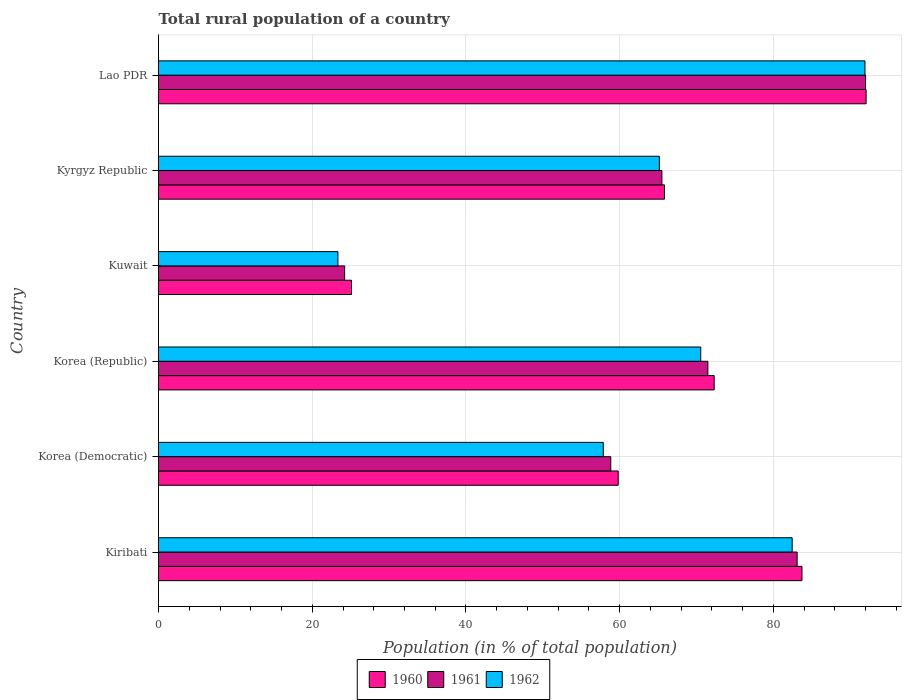How many different coloured bars are there?
Your response must be concise. 3. How many groups of bars are there?
Provide a succinct answer. 6. Are the number of bars per tick equal to the number of legend labels?
Provide a short and direct response. Yes. Are the number of bars on each tick of the Y-axis equal?
Your response must be concise. Yes. What is the label of the 2nd group of bars from the top?
Offer a terse response. Kyrgyz Republic. What is the rural population in 1962 in Kiribati?
Keep it short and to the point. 82.43. Across all countries, what is the maximum rural population in 1961?
Your answer should be compact. 91.98. Across all countries, what is the minimum rural population in 1960?
Offer a very short reply. 25.11. In which country was the rural population in 1962 maximum?
Offer a very short reply. Lao PDR. In which country was the rural population in 1961 minimum?
Make the answer very short. Kuwait. What is the total rural population in 1961 in the graph?
Your answer should be compact. 395.07. What is the difference between the rural population in 1960 in Korea (Democratic) and that in Kuwait?
Your answer should be compact. 34.7. What is the difference between the rural population in 1961 in Lao PDR and the rural population in 1962 in Korea (Democratic)?
Offer a very short reply. 34.12. What is the average rural population in 1962 per country?
Offer a very short reply. 65.21. What is the difference between the rural population in 1961 and rural population in 1960 in Kiribati?
Provide a short and direct response. -0.63. In how many countries, is the rural population in 1962 greater than 68 %?
Provide a succinct answer. 3. What is the ratio of the rural population in 1960 in Kiribati to that in Korea (Republic)?
Give a very brief answer. 1.16. What is the difference between the highest and the second highest rural population in 1960?
Ensure brevity in your answer.  8.34. What is the difference between the highest and the lowest rural population in 1960?
Make the answer very short. 66.95. Is the sum of the rural population in 1960 in Kyrgyz Republic and Lao PDR greater than the maximum rural population in 1962 across all countries?
Offer a terse response. Yes. What does the 1st bar from the bottom in Kyrgyz Republic represents?
Provide a short and direct response. 1960. Are all the bars in the graph horizontal?
Provide a succinct answer. Yes. How many countries are there in the graph?
Make the answer very short. 6. What is the difference between two consecutive major ticks on the X-axis?
Offer a terse response. 20. Does the graph contain any zero values?
Offer a terse response. No. Does the graph contain grids?
Ensure brevity in your answer.  Yes. Where does the legend appear in the graph?
Provide a succinct answer. Bottom center. How are the legend labels stacked?
Make the answer very short. Horizontal. What is the title of the graph?
Offer a very short reply. Total rural population of a country. What is the label or title of the X-axis?
Your response must be concise. Population (in % of total population). What is the Population (in % of total population) in 1960 in Kiribati?
Give a very brief answer. 83.71. What is the Population (in % of total population) in 1961 in Kiribati?
Ensure brevity in your answer.  83.08. What is the Population (in % of total population) in 1962 in Kiribati?
Your answer should be very brief. 82.43. What is the Population (in % of total population) in 1960 in Korea (Democratic)?
Offer a terse response. 59.8. What is the Population (in % of total population) in 1961 in Korea (Democratic)?
Your response must be concise. 58.84. What is the Population (in % of total population) in 1962 in Korea (Democratic)?
Your answer should be very brief. 57.86. What is the Population (in % of total population) in 1960 in Korea (Republic)?
Your answer should be very brief. 72.29. What is the Population (in % of total population) in 1961 in Korea (Republic)?
Keep it short and to the point. 71.47. What is the Population (in % of total population) of 1962 in Korea (Republic)?
Provide a succinct answer. 70.54. What is the Population (in % of total population) in 1960 in Kuwait?
Provide a succinct answer. 25.11. What is the Population (in % of total population) in 1961 in Kuwait?
Ensure brevity in your answer.  24.21. What is the Population (in % of total population) in 1962 in Kuwait?
Offer a very short reply. 23.34. What is the Population (in % of total population) in 1960 in Kyrgyz Republic?
Ensure brevity in your answer.  65.82. What is the Population (in % of total population) of 1961 in Kyrgyz Republic?
Provide a succinct answer. 65.49. What is the Population (in % of total population) of 1962 in Kyrgyz Republic?
Provide a succinct answer. 65.16. What is the Population (in % of total population) of 1960 in Lao PDR?
Make the answer very short. 92.05. What is the Population (in % of total population) in 1961 in Lao PDR?
Offer a very short reply. 91.98. What is the Population (in % of total population) in 1962 in Lao PDR?
Offer a very short reply. 91.91. Across all countries, what is the maximum Population (in % of total population) in 1960?
Your answer should be very brief. 92.05. Across all countries, what is the maximum Population (in % of total population) in 1961?
Make the answer very short. 91.98. Across all countries, what is the maximum Population (in % of total population) of 1962?
Ensure brevity in your answer.  91.91. Across all countries, what is the minimum Population (in % of total population) in 1960?
Ensure brevity in your answer.  25.11. Across all countries, what is the minimum Population (in % of total population) in 1961?
Offer a terse response. 24.21. Across all countries, what is the minimum Population (in % of total population) in 1962?
Your answer should be very brief. 23.34. What is the total Population (in % of total population) of 1960 in the graph?
Provide a succinct answer. 398.79. What is the total Population (in % of total population) of 1961 in the graph?
Offer a terse response. 395.07. What is the total Population (in % of total population) of 1962 in the graph?
Ensure brevity in your answer.  391.24. What is the difference between the Population (in % of total population) in 1960 in Kiribati and that in Korea (Democratic)?
Offer a very short reply. 23.91. What is the difference between the Population (in % of total population) in 1961 in Kiribati and that in Korea (Democratic)?
Offer a terse response. 24.24. What is the difference between the Population (in % of total population) of 1962 in Kiribati and that in Korea (Democratic)?
Offer a terse response. 24.57. What is the difference between the Population (in % of total population) in 1960 in Kiribati and that in Korea (Republic)?
Your answer should be compact. 11.42. What is the difference between the Population (in % of total population) in 1961 in Kiribati and that in Korea (Republic)?
Provide a succinct answer. 11.61. What is the difference between the Population (in % of total population) in 1962 in Kiribati and that in Korea (Republic)?
Make the answer very short. 11.89. What is the difference between the Population (in % of total population) in 1960 in Kiribati and that in Kuwait?
Keep it short and to the point. 58.6. What is the difference between the Population (in % of total population) of 1961 in Kiribati and that in Kuwait?
Offer a terse response. 58.87. What is the difference between the Population (in % of total population) in 1962 in Kiribati and that in Kuwait?
Provide a succinct answer. 59.09. What is the difference between the Population (in % of total population) of 1960 in Kiribati and that in Kyrgyz Republic?
Give a very brief answer. 17.89. What is the difference between the Population (in % of total population) in 1961 in Kiribati and that in Kyrgyz Republic?
Provide a succinct answer. 17.59. What is the difference between the Population (in % of total population) of 1962 in Kiribati and that in Kyrgyz Republic?
Ensure brevity in your answer.  17.28. What is the difference between the Population (in % of total population) of 1960 in Kiribati and that in Lao PDR?
Provide a succinct answer. -8.34. What is the difference between the Population (in % of total population) of 1961 in Kiribati and that in Lao PDR?
Your answer should be very brief. -8.9. What is the difference between the Population (in % of total population) of 1962 in Kiribati and that in Lao PDR?
Provide a succinct answer. -9.47. What is the difference between the Population (in % of total population) of 1960 in Korea (Democratic) and that in Korea (Republic)?
Make the answer very short. -12.48. What is the difference between the Population (in % of total population) in 1961 in Korea (Democratic) and that in Korea (Republic)?
Your response must be concise. -12.63. What is the difference between the Population (in % of total population) in 1962 in Korea (Democratic) and that in Korea (Republic)?
Your response must be concise. -12.68. What is the difference between the Population (in % of total population) in 1960 in Korea (Democratic) and that in Kuwait?
Your answer should be compact. 34.7. What is the difference between the Population (in % of total population) of 1961 in Korea (Democratic) and that in Kuwait?
Provide a short and direct response. 34.62. What is the difference between the Population (in % of total population) of 1962 in Korea (Democratic) and that in Kuwait?
Your response must be concise. 34.52. What is the difference between the Population (in % of total population) in 1960 in Korea (Democratic) and that in Kyrgyz Republic?
Give a very brief answer. -6.01. What is the difference between the Population (in % of total population) of 1961 in Korea (Democratic) and that in Kyrgyz Republic?
Your answer should be very brief. -6.65. What is the difference between the Population (in % of total population) of 1962 in Korea (Democratic) and that in Kyrgyz Republic?
Keep it short and to the point. -7.29. What is the difference between the Population (in % of total population) in 1960 in Korea (Democratic) and that in Lao PDR?
Your answer should be compact. -32.25. What is the difference between the Population (in % of total population) in 1961 in Korea (Democratic) and that in Lao PDR?
Offer a very short reply. -33.14. What is the difference between the Population (in % of total population) of 1962 in Korea (Democratic) and that in Lao PDR?
Offer a very short reply. -34.04. What is the difference between the Population (in % of total population) of 1960 in Korea (Republic) and that in Kuwait?
Provide a succinct answer. 47.18. What is the difference between the Population (in % of total population) of 1961 in Korea (Republic) and that in Kuwait?
Provide a succinct answer. 47.26. What is the difference between the Population (in % of total population) in 1962 in Korea (Republic) and that in Kuwait?
Your answer should be very brief. 47.2. What is the difference between the Population (in % of total population) of 1960 in Korea (Republic) and that in Kyrgyz Republic?
Offer a terse response. 6.47. What is the difference between the Population (in % of total population) in 1961 in Korea (Republic) and that in Kyrgyz Republic?
Ensure brevity in your answer.  5.98. What is the difference between the Population (in % of total population) in 1962 in Korea (Republic) and that in Kyrgyz Republic?
Offer a very short reply. 5.38. What is the difference between the Population (in % of total population) of 1960 in Korea (Republic) and that in Lao PDR?
Give a very brief answer. -19.76. What is the difference between the Population (in % of total population) of 1961 in Korea (Republic) and that in Lao PDR?
Offer a terse response. -20.51. What is the difference between the Population (in % of total population) in 1962 in Korea (Republic) and that in Lao PDR?
Offer a terse response. -21.37. What is the difference between the Population (in % of total population) in 1960 in Kuwait and that in Kyrgyz Republic?
Your answer should be very brief. -40.71. What is the difference between the Population (in % of total population) of 1961 in Kuwait and that in Kyrgyz Republic?
Offer a terse response. -41.28. What is the difference between the Population (in % of total population) of 1962 in Kuwait and that in Kyrgyz Republic?
Keep it short and to the point. -41.82. What is the difference between the Population (in % of total population) in 1960 in Kuwait and that in Lao PDR?
Keep it short and to the point. -66.95. What is the difference between the Population (in % of total population) of 1961 in Kuwait and that in Lao PDR?
Your answer should be very brief. -67.77. What is the difference between the Population (in % of total population) of 1962 in Kuwait and that in Lao PDR?
Your response must be concise. -68.56. What is the difference between the Population (in % of total population) in 1960 in Kyrgyz Republic and that in Lao PDR?
Provide a succinct answer. -26.23. What is the difference between the Population (in % of total population) in 1961 in Kyrgyz Republic and that in Lao PDR?
Make the answer very short. -26.49. What is the difference between the Population (in % of total population) in 1962 in Kyrgyz Republic and that in Lao PDR?
Your answer should be compact. -26.75. What is the difference between the Population (in % of total population) in 1960 in Kiribati and the Population (in % of total population) in 1961 in Korea (Democratic)?
Keep it short and to the point. 24.87. What is the difference between the Population (in % of total population) of 1960 in Kiribati and the Population (in % of total population) of 1962 in Korea (Democratic)?
Give a very brief answer. 25.85. What is the difference between the Population (in % of total population) in 1961 in Kiribati and the Population (in % of total population) in 1962 in Korea (Democratic)?
Your answer should be compact. 25.22. What is the difference between the Population (in % of total population) in 1960 in Kiribati and the Population (in % of total population) in 1961 in Korea (Republic)?
Keep it short and to the point. 12.24. What is the difference between the Population (in % of total population) in 1960 in Kiribati and the Population (in % of total population) in 1962 in Korea (Republic)?
Offer a terse response. 13.17. What is the difference between the Population (in % of total population) in 1961 in Kiribati and the Population (in % of total population) in 1962 in Korea (Republic)?
Your answer should be compact. 12.54. What is the difference between the Population (in % of total population) of 1960 in Kiribati and the Population (in % of total population) of 1961 in Kuwait?
Offer a terse response. 59.5. What is the difference between the Population (in % of total population) of 1960 in Kiribati and the Population (in % of total population) of 1962 in Kuwait?
Provide a succinct answer. 60.37. What is the difference between the Population (in % of total population) of 1961 in Kiribati and the Population (in % of total population) of 1962 in Kuwait?
Ensure brevity in your answer.  59.74. What is the difference between the Population (in % of total population) of 1960 in Kiribati and the Population (in % of total population) of 1961 in Kyrgyz Republic?
Ensure brevity in your answer.  18.22. What is the difference between the Population (in % of total population) in 1960 in Kiribati and the Population (in % of total population) in 1962 in Kyrgyz Republic?
Your response must be concise. 18.55. What is the difference between the Population (in % of total population) in 1961 in Kiribati and the Population (in % of total population) in 1962 in Kyrgyz Republic?
Keep it short and to the point. 17.93. What is the difference between the Population (in % of total population) of 1960 in Kiribati and the Population (in % of total population) of 1961 in Lao PDR?
Offer a terse response. -8.27. What is the difference between the Population (in % of total population) of 1960 in Kiribati and the Population (in % of total population) of 1962 in Lao PDR?
Offer a terse response. -8.2. What is the difference between the Population (in % of total population) in 1961 in Kiribati and the Population (in % of total population) in 1962 in Lao PDR?
Your answer should be compact. -8.82. What is the difference between the Population (in % of total population) in 1960 in Korea (Democratic) and the Population (in % of total population) in 1961 in Korea (Republic)?
Your answer should be compact. -11.66. What is the difference between the Population (in % of total population) in 1960 in Korea (Democratic) and the Population (in % of total population) in 1962 in Korea (Republic)?
Make the answer very short. -10.73. What is the difference between the Population (in % of total population) in 1961 in Korea (Democratic) and the Population (in % of total population) in 1962 in Korea (Republic)?
Keep it short and to the point. -11.7. What is the difference between the Population (in % of total population) of 1960 in Korea (Democratic) and the Population (in % of total population) of 1961 in Kuwait?
Your response must be concise. 35.59. What is the difference between the Population (in % of total population) of 1960 in Korea (Democratic) and the Population (in % of total population) of 1962 in Kuwait?
Offer a terse response. 36.47. What is the difference between the Population (in % of total population) of 1961 in Korea (Democratic) and the Population (in % of total population) of 1962 in Kuwait?
Ensure brevity in your answer.  35.5. What is the difference between the Population (in % of total population) in 1960 in Korea (Democratic) and the Population (in % of total population) in 1961 in Kyrgyz Republic?
Give a very brief answer. -5.68. What is the difference between the Population (in % of total population) of 1960 in Korea (Democratic) and the Population (in % of total population) of 1962 in Kyrgyz Republic?
Keep it short and to the point. -5.35. What is the difference between the Population (in % of total population) in 1961 in Korea (Democratic) and the Population (in % of total population) in 1962 in Kyrgyz Republic?
Your response must be concise. -6.32. What is the difference between the Population (in % of total population) in 1960 in Korea (Democratic) and the Population (in % of total population) in 1961 in Lao PDR?
Offer a very short reply. -32.17. What is the difference between the Population (in % of total population) of 1960 in Korea (Democratic) and the Population (in % of total population) of 1962 in Lao PDR?
Offer a terse response. -32.1. What is the difference between the Population (in % of total population) in 1961 in Korea (Democratic) and the Population (in % of total population) in 1962 in Lao PDR?
Give a very brief answer. -33.07. What is the difference between the Population (in % of total population) in 1960 in Korea (Republic) and the Population (in % of total population) in 1961 in Kuwait?
Keep it short and to the point. 48.08. What is the difference between the Population (in % of total population) in 1960 in Korea (Republic) and the Population (in % of total population) in 1962 in Kuwait?
Your answer should be compact. 48.95. What is the difference between the Population (in % of total population) of 1961 in Korea (Republic) and the Population (in % of total population) of 1962 in Kuwait?
Give a very brief answer. 48.13. What is the difference between the Population (in % of total population) of 1960 in Korea (Republic) and the Population (in % of total population) of 1961 in Kyrgyz Republic?
Provide a succinct answer. 6.8. What is the difference between the Population (in % of total population) in 1960 in Korea (Republic) and the Population (in % of total population) in 1962 in Kyrgyz Republic?
Your answer should be compact. 7.13. What is the difference between the Population (in % of total population) in 1961 in Korea (Republic) and the Population (in % of total population) in 1962 in Kyrgyz Republic?
Your answer should be compact. 6.31. What is the difference between the Population (in % of total population) in 1960 in Korea (Republic) and the Population (in % of total population) in 1961 in Lao PDR?
Keep it short and to the point. -19.69. What is the difference between the Population (in % of total population) of 1960 in Korea (Republic) and the Population (in % of total population) of 1962 in Lao PDR?
Give a very brief answer. -19.61. What is the difference between the Population (in % of total population) of 1961 in Korea (Republic) and the Population (in % of total population) of 1962 in Lao PDR?
Ensure brevity in your answer.  -20.44. What is the difference between the Population (in % of total population) of 1960 in Kuwait and the Population (in % of total population) of 1961 in Kyrgyz Republic?
Keep it short and to the point. -40.38. What is the difference between the Population (in % of total population) in 1960 in Kuwait and the Population (in % of total population) in 1962 in Kyrgyz Republic?
Provide a short and direct response. -40.05. What is the difference between the Population (in % of total population) of 1961 in Kuwait and the Population (in % of total population) of 1962 in Kyrgyz Republic?
Your answer should be very brief. -40.94. What is the difference between the Population (in % of total population) of 1960 in Kuwait and the Population (in % of total population) of 1961 in Lao PDR?
Make the answer very short. -66.87. What is the difference between the Population (in % of total population) in 1960 in Kuwait and the Population (in % of total population) in 1962 in Lao PDR?
Make the answer very short. -66.8. What is the difference between the Population (in % of total population) of 1961 in Kuwait and the Population (in % of total population) of 1962 in Lao PDR?
Your response must be concise. -67.69. What is the difference between the Population (in % of total population) of 1960 in Kyrgyz Republic and the Population (in % of total population) of 1961 in Lao PDR?
Make the answer very short. -26.16. What is the difference between the Population (in % of total population) in 1960 in Kyrgyz Republic and the Population (in % of total population) in 1962 in Lao PDR?
Offer a terse response. -26.09. What is the difference between the Population (in % of total population) in 1961 in Kyrgyz Republic and the Population (in % of total population) in 1962 in Lao PDR?
Give a very brief answer. -26.42. What is the average Population (in % of total population) of 1960 per country?
Give a very brief answer. 66.46. What is the average Population (in % of total population) of 1961 per country?
Provide a short and direct response. 65.85. What is the average Population (in % of total population) in 1962 per country?
Provide a succinct answer. 65.21. What is the difference between the Population (in % of total population) of 1960 and Population (in % of total population) of 1961 in Kiribati?
Offer a terse response. 0.63. What is the difference between the Population (in % of total population) in 1960 and Population (in % of total population) in 1962 in Kiribati?
Provide a short and direct response. 1.28. What is the difference between the Population (in % of total population) in 1961 and Population (in % of total population) in 1962 in Kiribati?
Provide a succinct answer. 0.65. What is the difference between the Population (in % of total population) of 1960 and Population (in % of total population) of 1961 in Korea (Democratic)?
Provide a short and direct response. 0.97. What is the difference between the Population (in % of total population) in 1960 and Population (in % of total population) in 1962 in Korea (Democratic)?
Ensure brevity in your answer.  1.94. What is the difference between the Population (in % of total population) of 1961 and Population (in % of total population) of 1962 in Korea (Democratic)?
Your answer should be compact. 0.97. What is the difference between the Population (in % of total population) of 1960 and Population (in % of total population) of 1961 in Korea (Republic)?
Give a very brief answer. 0.82. What is the difference between the Population (in % of total population) of 1960 and Population (in % of total population) of 1962 in Korea (Republic)?
Your response must be concise. 1.75. What is the difference between the Population (in % of total population) of 1961 and Population (in % of total population) of 1962 in Korea (Republic)?
Offer a very short reply. 0.93. What is the difference between the Population (in % of total population) of 1960 and Population (in % of total population) of 1961 in Kuwait?
Offer a very short reply. 0.89. What is the difference between the Population (in % of total population) of 1960 and Population (in % of total population) of 1962 in Kuwait?
Your answer should be very brief. 1.77. What is the difference between the Population (in % of total population) of 1961 and Population (in % of total population) of 1962 in Kuwait?
Your response must be concise. 0.87. What is the difference between the Population (in % of total population) of 1960 and Population (in % of total population) of 1961 in Kyrgyz Republic?
Keep it short and to the point. 0.33. What is the difference between the Population (in % of total population) in 1960 and Population (in % of total population) in 1962 in Kyrgyz Republic?
Your answer should be compact. 0.66. What is the difference between the Population (in % of total population) in 1961 and Population (in % of total population) in 1962 in Kyrgyz Republic?
Give a very brief answer. 0.33. What is the difference between the Population (in % of total population) of 1960 and Population (in % of total population) of 1961 in Lao PDR?
Provide a short and direct response. 0.07. What is the difference between the Population (in % of total population) of 1960 and Population (in % of total population) of 1962 in Lao PDR?
Provide a short and direct response. 0.15. What is the difference between the Population (in % of total population) of 1961 and Population (in % of total population) of 1962 in Lao PDR?
Provide a short and direct response. 0.07. What is the ratio of the Population (in % of total population) in 1960 in Kiribati to that in Korea (Democratic)?
Give a very brief answer. 1.4. What is the ratio of the Population (in % of total population) of 1961 in Kiribati to that in Korea (Democratic)?
Offer a terse response. 1.41. What is the ratio of the Population (in % of total population) in 1962 in Kiribati to that in Korea (Democratic)?
Ensure brevity in your answer.  1.42. What is the ratio of the Population (in % of total population) of 1960 in Kiribati to that in Korea (Republic)?
Offer a terse response. 1.16. What is the ratio of the Population (in % of total population) in 1961 in Kiribati to that in Korea (Republic)?
Offer a terse response. 1.16. What is the ratio of the Population (in % of total population) of 1962 in Kiribati to that in Korea (Republic)?
Offer a terse response. 1.17. What is the ratio of the Population (in % of total population) of 1960 in Kiribati to that in Kuwait?
Your answer should be compact. 3.33. What is the ratio of the Population (in % of total population) of 1961 in Kiribati to that in Kuwait?
Offer a terse response. 3.43. What is the ratio of the Population (in % of total population) in 1962 in Kiribati to that in Kuwait?
Your answer should be compact. 3.53. What is the ratio of the Population (in % of total population) of 1960 in Kiribati to that in Kyrgyz Republic?
Your answer should be very brief. 1.27. What is the ratio of the Population (in % of total population) in 1961 in Kiribati to that in Kyrgyz Republic?
Make the answer very short. 1.27. What is the ratio of the Population (in % of total population) of 1962 in Kiribati to that in Kyrgyz Republic?
Give a very brief answer. 1.27. What is the ratio of the Population (in % of total population) in 1960 in Kiribati to that in Lao PDR?
Your response must be concise. 0.91. What is the ratio of the Population (in % of total population) of 1961 in Kiribati to that in Lao PDR?
Provide a succinct answer. 0.9. What is the ratio of the Population (in % of total population) in 1962 in Kiribati to that in Lao PDR?
Keep it short and to the point. 0.9. What is the ratio of the Population (in % of total population) in 1960 in Korea (Democratic) to that in Korea (Republic)?
Give a very brief answer. 0.83. What is the ratio of the Population (in % of total population) in 1961 in Korea (Democratic) to that in Korea (Republic)?
Make the answer very short. 0.82. What is the ratio of the Population (in % of total population) of 1962 in Korea (Democratic) to that in Korea (Republic)?
Keep it short and to the point. 0.82. What is the ratio of the Population (in % of total population) in 1960 in Korea (Democratic) to that in Kuwait?
Keep it short and to the point. 2.38. What is the ratio of the Population (in % of total population) in 1961 in Korea (Democratic) to that in Kuwait?
Ensure brevity in your answer.  2.43. What is the ratio of the Population (in % of total population) in 1962 in Korea (Democratic) to that in Kuwait?
Give a very brief answer. 2.48. What is the ratio of the Population (in % of total population) of 1960 in Korea (Democratic) to that in Kyrgyz Republic?
Provide a short and direct response. 0.91. What is the ratio of the Population (in % of total population) in 1961 in Korea (Democratic) to that in Kyrgyz Republic?
Give a very brief answer. 0.9. What is the ratio of the Population (in % of total population) of 1962 in Korea (Democratic) to that in Kyrgyz Republic?
Your answer should be compact. 0.89. What is the ratio of the Population (in % of total population) in 1960 in Korea (Democratic) to that in Lao PDR?
Keep it short and to the point. 0.65. What is the ratio of the Population (in % of total population) of 1961 in Korea (Democratic) to that in Lao PDR?
Your answer should be very brief. 0.64. What is the ratio of the Population (in % of total population) of 1962 in Korea (Democratic) to that in Lao PDR?
Offer a terse response. 0.63. What is the ratio of the Population (in % of total population) of 1960 in Korea (Republic) to that in Kuwait?
Ensure brevity in your answer.  2.88. What is the ratio of the Population (in % of total population) of 1961 in Korea (Republic) to that in Kuwait?
Give a very brief answer. 2.95. What is the ratio of the Population (in % of total population) in 1962 in Korea (Republic) to that in Kuwait?
Offer a very short reply. 3.02. What is the ratio of the Population (in % of total population) of 1960 in Korea (Republic) to that in Kyrgyz Republic?
Provide a short and direct response. 1.1. What is the ratio of the Population (in % of total population) of 1961 in Korea (Republic) to that in Kyrgyz Republic?
Offer a very short reply. 1.09. What is the ratio of the Population (in % of total population) of 1962 in Korea (Republic) to that in Kyrgyz Republic?
Provide a succinct answer. 1.08. What is the ratio of the Population (in % of total population) in 1960 in Korea (Republic) to that in Lao PDR?
Make the answer very short. 0.79. What is the ratio of the Population (in % of total population) in 1961 in Korea (Republic) to that in Lao PDR?
Make the answer very short. 0.78. What is the ratio of the Population (in % of total population) of 1962 in Korea (Republic) to that in Lao PDR?
Give a very brief answer. 0.77. What is the ratio of the Population (in % of total population) in 1960 in Kuwait to that in Kyrgyz Republic?
Provide a short and direct response. 0.38. What is the ratio of the Population (in % of total population) of 1961 in Kuwait to that in Kyrgyz Republic?
Give a very brief answer. 0.37. What is the ratio of the Population (in % of total population) in 1962 in Kuwait to that in Kyrgyz Republic?
Provide a succinct answer. 0.36. What is the ratio of the Population (in % of total population) in 1960 in Kuwait to that in Lao PDR?
Your answer should be very brief. 0.27. What is the ratio of the Population (in % of total population) in 1961 in Kuwait to that in Lao PDR?
Make the answer very short. 0.26. What is the ratio of the Population (in % of total population) of 1962 in Kuwait to that in Lao PDR?
Give a very brief answer. 0.25. What is the ratio of the Population (in % of total population) in 1960 in Kyrgyz Republic to that in Lao PDR?
Ensure brevity in your answer.  0.71. What is the ratio of the Population (in % of total population) in 1961 in Kyrgyz Republic to that in Lao PDR?
Your response must be concise. 0.71. What is the ratio of the Population (in % of total population) of 1962 in Kyrgyz Republic to that in Lao PDR?
Your answer should be very brief. 0.71. What is the difference between the highest and the second highest Population (in % of total population) of 1960?
Ensure brevity in your answer.  8.34. What is the difference between the highest and the second highest Population (in % of total population) in 1961?
Your answer should be compact. 8.9. What is the difference between the highest and the second highest Population (in % of total population) in 1962?
Give a very brief answer. 9.47. What is the difference between the highest and the lowest Population (in % of total population) of 1960?
Give a very brief answer. 66.95. What is the difference between the highest and the lowest Population (in % of total population) of 1961?
Your answer should be very brief. 67.77. What is the difference between the highest and the lowest Population (in % of total population) of 1962?
Provide a succinct answer. 68.56. 